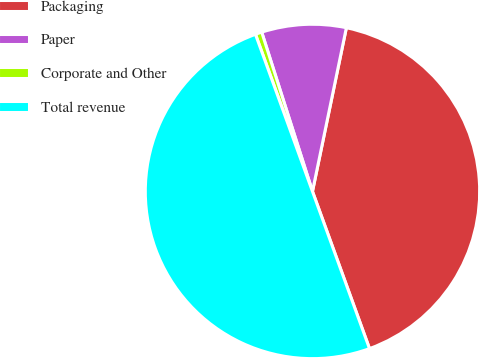Convert chart. <chart><loc_0><loc_0><loc_500><loc_500><pie_chart><fcel>Packaging<fcel>Paper<fcel>Corporate and Other<fcel>Total revenue<nl><fcel>41.21%<fcel>8.16%<fcel>0.63%<fcel>50.0%<nl></chart> 